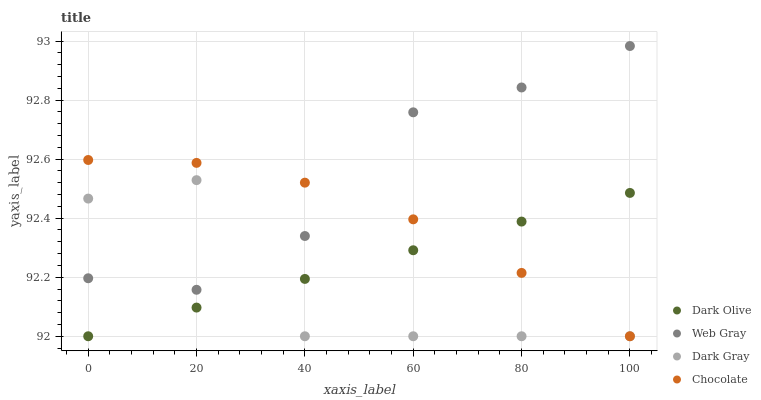Does Dark Gray have the minimum area under the curve?
Answer yes or no. Yes. Does Web Gray have the maximum area under the curve?
Answer yes or no. Yes. Does Dark Olive have the minimum area under the curve?
Answer yes or no. No. Does Dark Olive have the maximum area under the curve?
Answer yes or no. No. Is Dark Olive the smoothest?
Answer yes or no. Yes. Is Dark Gray the roughest?
Answer yes or no. Yes. Is Web Gray the smoothest?
Answer yes or no. No. Is Web Gray the roughest?
Answer yes or no. No. Does Dark Gray have the lowest value?
Answer yes or no. Yes. Does Web Gray have the lowest value?
Answer yes or no. No. Does Web Gray have the highest value?
Answer yes or no. Yes. Does Dark Olive have the highest value?
Answer yes or no. No. Is Dark Olive less than Web Gray?
Answer yes or no. Yes. Is Web Gray greater than Dark Olive?
Answer yes or no. Yes. Does Chocolate intersect Web Gray?
Answer yes or no. Yes. Is Chocolate less than Web Gray?
Answer yes or no. No. Is Chocolate greater than Web Gray?
Answer yes or no. No. Does Dark Olive intersect Web Gray?
Answer yes or no. No. 